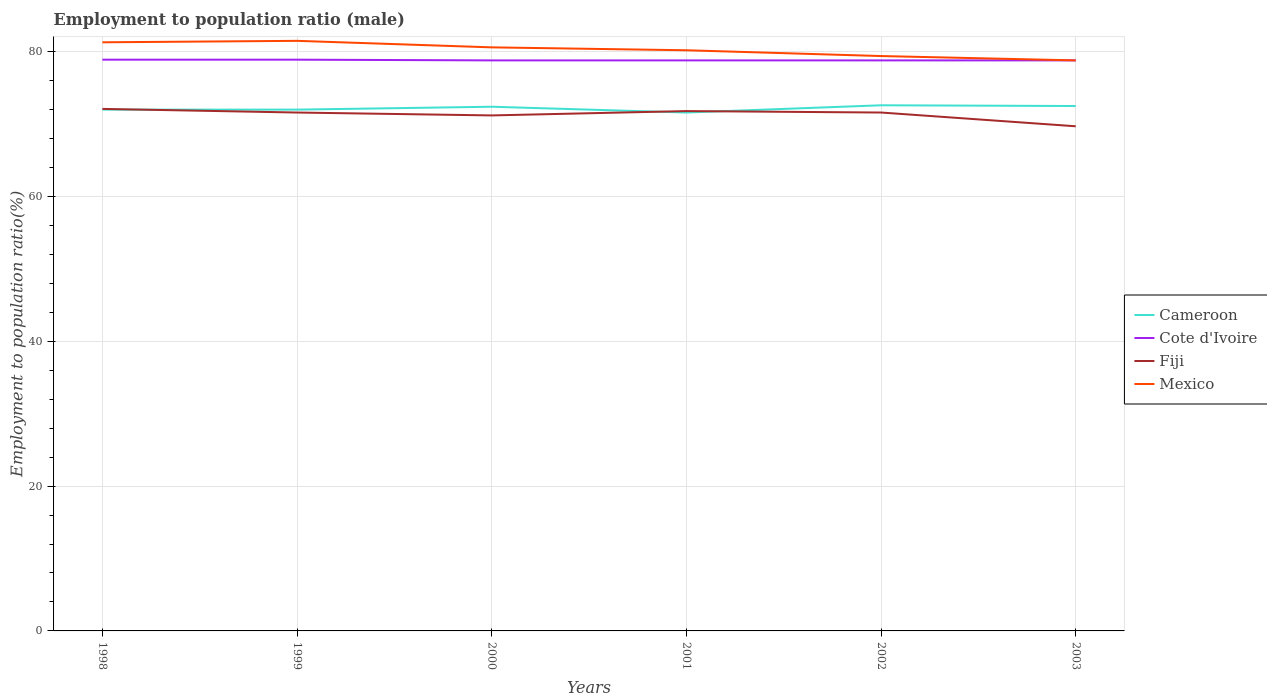Does the line corresponding to Mexico intersect with the line corresponding to Cote d'Ivoire?
Keep it short and to the point. Yes. Across all years, what is the maximum employment to population ratio in Cote d'Ivoire?
Your answer should be very brief. 78.8. What is the total employment to population ratio in Cote d'Ivoire in the graph?
Offer a terse response. 0.1. What is the difference between the highest and the second highest employment to population ratio in Mexico?
Your response must be concise. 2.7. How many lines are there?
Your answer should be very brief. 4. What is the difference between two consecutive major ticks on the Y-axis?
Offer a terse response. 20. Are the values on the major ticks of Y-axis written in scientific E-notation?
Offer a very short reply. No. How many legend labels are there?
Your answer should be compact. 4. How are the legend labels stacked?
Give a very brief answer. Vertical. What is the title of the graph?
Give a very brief answer. Employment to population ratio (male). Does "East Asia (all income levels)" appear as one of the legend labels in the graph?
Make the answer very short. No. What is the Employment to population ratio(%) in Cameroon in 1998?
Offer a terse response. 72. What is the Employment to population ratio(%) in Cote d'Ivoire in 1998?
Your answer should be very brief. 78.9. What is the Employment to population ratio(%) in Fiji in 1998?
Your answer should be compact. 72.1. What is the Employment to population ratio(%) in Mexico in 1998?
Offer a terse response. 81.3. What is the Employment to population ratio(%) in Cote d'Ivoire in 1999?
Offer a very short reply. 78.9. What is the Employment to population ratio(%) of Fiji in 1999?
Give a very brief answer. 71.6. What is the Employment to population ratio(%) in Mexico in 1999?
Offer a terse response. 81.5. What is the Employment to population ratio(%) of Cameroon in 2000?
Provide a succinct answer. 72.4. What is the Employment to population ratio(%) of Cote d'Ivoire in 2000?
Give a very brief answer. 78.8. What is the Employment to population ratio(%) of Fiji in 2000?
Keep it short and to the point. 71.2. What is the Employment to population ratio(%) of Mexico in 2000?
Make the answer very short. 80.6. What is the Employment to population ratio(%) of Cameroon in 2001?
Make the answer very short. 71.6. What is the Employment to population ratio(%) of Cote d'Ivoire in 2001?
Make the answer very short. 78.8. What is the Employment to population ratio(%) in Fiji in 2001?
Give a very brief answer. 71.8. What is the Employment to population ratio(%) of Mexico in 2001?
Offer a terse response. 80.2. What is the Employment to population ratio(%) of Cameroon in 2002?
Provide a succinct answer. 72.6. What is the Employment to population ratio(%) of Cote d'Ivoire in 2002?
Make the answer very short. 78.8. What is the Employment to population ratio(%) in Fiji in 2002?
Provide a short and direct response. 71.6. What is the Employment to population ratio(%) in Mexico in 2002?
Your answer should be compact. 79.4. What is the Employment to population ratio(%) in Cameroon in 2003?
Offer a terse response. 72.5. What is the Employment to population ratio(%) of Cote d'Ivoire in 2003?
Keep it short and to the point. 78.8. What is the Employment to population ratio(%) in Fiji in 2003?
Provide a short and direct response. 69.7. What is the Employment to population ratio(%) in Mexico in 2003?
Your answer should be very brief. 78.8. Across all years, what is the maximum Employment to population ratio(%) in Cameroon?
Provide a short and direct response. 72.6. Across all years, what is the maximum Employment to population ratio(%) in Cote d'Ivoire?
Keep it short and to the point. 78.9. Across all years, what is the maximum Employment to population ratio(%) of Fiji?
Ensure brevity in your answer.  72.1. Across all years, what is the maximum Employment to population ratio(%) in Mexico?
Offer a terse response. 81.5. Across all years, what is the minimum Employment to population ratio(%) in Cameroon?
Your response must be concise. 71.6. Across all years, what is the minimum Employment to population ratio(%) of Cote d'Ivoire?
Keep it short and to the point. 78.8. Across all years, what is the minimum Employment to population ratio(%) of Fiji?
Provide a succinct answer. 69.7. Across all years, what is the minimum Employment to population ratio(%) of Mexico?
Your response must be concise. 78.8. What is the total Employment to population ratio(%) of Cameroon in the graph?
Give a very brief answer. 433.1. What is the total Employment to population ratio(%) in Cote d'Ivoire in the graph?
Ensure brevity in your answer.  473. What is the total Employment to population ratio(%) in Fiji in the graph?
Provide a succinct answer. 428. What is the total Employment to population ratio(%) in Mexico in the graph?
Ensure brevity in your answer.  481.8. What is the difference between the Employment to population ratio(%) in Cote d'Ivoire in 1998 and that in 1999?
Ensure brevity in your answer.  0. What is the difference between the Employment to population ratio(%) of Fiji in 1998 and that in 1999?
Your answer should be very brief. 0.5. What is the difference between the Employment to population ratio(%) in Fiji in 1998 and that in 2000?
Provide a short and direct response. 0.9. What is the difference between the Employment to population ratio(%) of Cameroon in 1998 and that in 2001?
Make the answer very short. 0.4. What is the difference between the Employment to population ratio(%) in Fiji in 1998 and that in 2001?
Offer a very short reply. 0.3. What is the difference between the Employment to population ratio(%) of Mexico in 1998 and that in 2001?
Provide a succinct answer. 1.1. What is the difference between the Employment to population ratio(%) of Cameroon in 1998 and that in 2002?
Offer a terse response. -0.6. What is the difference between the Employment to population ratio(%) of Cote d'Ivoire in 1998 and that in 2002?
Provide a succinct answer. 0.1. What is the difference between the Employment to population ratio(%) in Mexico in 1998 and that in 2002?
Your answer should be compact. 1.9. What is the difference between the Employment to population ratio(%) of Fiji in 1998 and that in 2003?
Ensure brevity in your answer.  2.4. What is the difference between the Employment to population ratio(%) of Cameroon in 1999 and that in 2000?
Your answer should be compact. -0.4. What is the difference between the Employment to population ratio(%) in Cote d'Ivoire in 1999 and that in 2000?
Make the answer very short. 0.1. What is the difference between the Employment to population ratio(%) of Fiji in 1999 and that in 2000?
Make the answer very short. 0.4. What is the difference between the Employment to population ratio(%) in Mexico in 1999 and that in 2000?
Your answer should be very brief. 0.9. What is the difference between the Employment to population ratio(%) of Cameroon in 1999 and that in 2001?
Ensure brevity in your answer.  0.4. What is the difference between the Employment to population ratio(%) of Cote d'Ivoire in 1999 and that in 2001?
Make the answer very short. 0.1. What is the difference between the Employment to population ratio(%) in Mexico in 1999 and that in 2001?
Ensure brevity in your answer.  1.3. What is the difference between the Employment to population ratio(%) of Cameroon in 1999 and that in 2002?
Keep it short and to the point. -0.6. What is the difference between the Employment to population ratio(%) in Cote d'Ivoire in 1999 and that in 2003?
Provide a short and direct response. 0.1. What is the difference between the Employment to population ratio(%) in Mexico in 1999 and that in 2003?
Your answer should be very brief. 2.7. What is the difference between the Employment to population ratio(%) in Cameroon in 2000 and that in 2001?
Provide a succinct answer. 0.8. What is the difference between the Employment to population ratio(%) of Fiji in 2000 and that in 2001?
Your answer should be very brief. -0.6. What is the difference between the Employment to population ratio(%) of Cameroon in 2000 and that in 2002?
Give a very brief answer. -0.2. What is the difference between the Employment to population ratio(%) in Fiji in 2000 and that in 2002?
Give a very brief answer. -0.4. What is the difference between the Employment to population ratio(%) in Cameroon in 2000 and that in 2003?
Offer a terse response. -0.1. What is the difference between the Employment to population ratio(%) of Cote d'Ivoire in 2000 and that in 2003?
Provide a succinct answer. 0. What is the difference between the Employment to population ratio(%) of Mexico in 2000 and that in 2003?
Keep it short and to the point. 1.8. What is the difference between the Employment to population ratio(%) of Fiji in 2001 and that in 2002?
Your response must be concise. 0.2. What is the difference between the Employment to population ratio(%) of Cameroon in 2001 and that in 2003?
Give a very brief answer. -0.9. What is the difference between the Employment to population ratio(%) of Cote d'Ivoire in 2001 and that in 2003?
Keep it short and to the point. 0. What is the difference between the Employment to population ratio(%) in Mexico in 2001 and that in 2003?
Your answer should be very brief. 1.4. What is the difference between the Employment to population ratio(%) of Fiji in 2002 and that in 2003?
Provide a short and direct response. 1.9. What is the difference between the Employment to population ratio(%) in Mexico in 2002 and that in 2003?
Your response must be concise. 0.6. What is the difference between the Employment to population ratio(%) in Cameroon in 1998 and the Employment to population ratio(%) in Cote d'Ivoire in 1999?
Your answer should be very brief. -6.9. What is the difference between the Employment to population ratio(%) in Cameroon in 1998 and the Employment to population ratio(%) in Mexico in 1999?
Your answer should be very brief. -9.5. What is the difference between the Employment to population ratio(%) of Cote d'Ivoire in 1998 and the Employment to population ratio(%) of Fiji in 1999?
Your response must be concise. 7.3. What is the difference between the Employment to population ratio(%) of Fiji in 1998 and the Employment to population ratio(%) of Mexico in 1999?
Provide a succinct answer. -9.4. What is the difference between the Employment to population ratio(%) in Cameroon in 1998 and the Employment to population ratio(%) in Mexico in 2000?
Your answer should be very brief. -8.6. What is the difference between the Employment to population ratio(%) of Fiji in 1998 and the Employment to population ratio(%) of Mexico in 2000?
Keep it short and to the point. -8.5. What is the difference between the Employment to population ratio(%) of Cameroon in 1998 and the Employment to population ratio(%) of Cote d'Ivoire in 2001?
Your answer should be compact. -6.8. What is the difference between the Employment to population ratio(%) of Cameroon in 1998 and the Employment to population ratio(%) of Fiji in 2001?
Your answer should be very brief. 0.2. What is the difference between the Employment to population ratio(%) in Cote d'Ivoire in 1998 and the Employment to population ratio(%) in Fiji in 2001?
Make the answer very short. 7.1. What is the difference between the Employment to population ratio(%) in Cameroon in 1998 and the Employment to population ratio(%) in Cote d'Ivoire in 2002?
Give a very brief answer. -6.8. What is the difference between the Employment to population ratio(%) in Cameroon in 1998 and the Employment to population ratio(%) in Fiji in 2002?
Give a very brief answer. 0.4. What is the difference between the Employment to population ratio(%) of Cameroon in 1998 and the Employment to population ratio(%) of Mexico in 2002?
Your answer should be compact. -7.4. What is the difference between the Employment to population ratio(%) in Fiji in 1998 and the Employment to population ratio(%) in Mexico in 2002?
Provide a succinct answer. -7.3. What is the difference between the Employment to population ratio(%) in Cameroon in 1998 and the Employment to population ratio(%) in Cote d'Ivoire in 2003?
Offer a terse response. -6.8. What is the difference between the Employment to population ratio(%) of Cameroon in 1998 and the Employment to population ratio(%) of Mexico in 2003?
Provide a short and direct response. -6.8. What is the difference between the Employment to population ratio(%) of Cote d'Ivoire in 1998 and the Employment to population ratio(%) of Fiji in 2003?
Your response must be concise. 9.2. What is the difference between the Employment to population ratio(%) of Cote d'Ivoire in 1998 and the Employment to population ratio(%) of Mexico in 2003?
Provide a succinct answer. 0.1. What is the difference between the Employment to population ratio(%) of Fiji in 1998 and the Employment to population ratio(%) of Mexico in 2003?
Give a very brief answer. -6.7. What is the difference between the Employment to population ratio(%) of Cameroon in 1999 and the Employment to population ratio(%) of Mexico in 2000?
Provide a succinct answer. -8.6. What is the difference between the Employment to population ratio(%) of Cote d'Ivoire in 1999 and the Employment to population ratio(%) of Fiji in 2000?
Make the answer very short. 7.7. What is the difference between the Employment to population ratio(%) of Cameroon in 1999 and the Employment to population ratio(%) of Cote d'Ivoire in 2001?
Make the answer very short. -6.8. What is the difference between the Employment to population ratio(%) of Cote d'Ivoire in 1999 and the Employment to population ratio(%) of Fiji in 2001?
Offer a terse response. 7.1. What is the difference between the Employment to population ratio(%) of Cote d'Ivoire in 1999 and the Employment to population ratio(%) of Mexico in 2001?
Provide a succinct answer. -1.3. What is the difference between the Employment to population ratio(%) in Cameroon in 1999 and the Employment to population ratio(%) in Cote d'Ivoire in 2002?
Offer a terse response. -6.8. What is the difference between the Employment to population ratio(%) in Cote d'Ivoire in 1999 and the Employment to population ratio(%) in Fiji in 2002?
Offer a terse response. 7.3. What is the difference between the Employment to population ratio(%) of Cameroon in 1999 and the Employment to population ratio(%) of Cote d'Ivoire in 2003?
Offer a terse response. -6.8. What is the difference between the Employment to population ratio(%) in Cote d'Ivoire in 1999 and the Employment to population ratio(%) in Mexico in 2003?
Make the answer very short. 0.1. What is the difference between the Employment to population ratio(%) of Cameroon in 2000 and the Employment to population ratio(%) of Mexico in 2001?
Keep it short and to the point. -7.8. What is the difference between the Employment to population ratio(%) of Fiji in 2000 and the Employment to population ratio(%) of Mexico in 2001?
Provide a short and direct response. -9. What is the difference between the Employment to population ratio(%) in Cameroon in 2000 and the Employment to population ratio(%) in Cote d'Ivoire in 2002?
Give a very brief answer. -6.4. What is the difference between the Employment to population ratio(%) of Cameroon in 2000 and the Employment to population ratio(%) of Mexico in 2002?
Ensure brevity in your answer.  -7. What is the difference between the Employment to population ratio(%) in Cote d'Ivoire in 2000 and the Employment to population ratio(%) in Fiji in 2002?
Ensure brevity in your answer.  7.2. What is the difference between the Employment to population ratio(%) of Cote d'Ivoire in 2000 and the Employment to population ratio(%) of Mexico in 2002?
Ensure brevity in your answer.  -0.6. What is the difference between the Employment to population ratio(%) of Fiji in 2000 and the Employment to population ratio(%) of Mexico in 2002?
Offer a very short reply. -8.2. What is the difference between the Employment to population ratio(%) in Cameroon in 2000 and the Employment to population ratio(%) in Cote d'Ivoire in 2003?
Keep it short and to the point. -6.4. What is the difference between the Employment to population ratio(%) of Cameroon in 2000 and the Employment to population ratio(%) of Fiji in 2003?
Your answer should be very brief. 2.7. What is the difference between the Employment to population ratio(%) in Cote d'Ivoire in 2000 and the Employment to population ratio(%) in Fiji in 2003?
Give a very brief answer. 9.1. What is the difference between the Employment to population ratio(%) in Cote d'Ivoire in 2000 and the Employment to population ratio(%) in Mexico in 2003?
Your answer should be very brief. 0. What is the difference between the Employment to population ratio(%) of Fiji in 2000 and the Employment to population ratio(%) of Mexico in 2003?
Offer a terse response. -7.6. What is the difference between the Employment to population ratio(%) of Cameroon in 2001 and the Employment to population ratio(%) of Mexico in 2002?
Provide a succinct answer. -7.8. What is the difference between the Employment to population ratio(%) of Cameroon in 2001 and the Employment to population ratio(%) of Cote d'Ivoire in 2003?
Provide a succinct answer. -7.2. What is the difference between the Employment to population ratio(%) in Cameroon in 2001 and the Employment to population ratio(%) in Mexico in 2003?
Provide a succinct answer. -7.2. What is the difference between the Employment to population ratio(%) in Cote d'Ivoire in 2001 and the Employment to population ratio(%) in Fiji in 2003?
Your answer should be compact. 9.1. What is the difference between the Employment to population ratio(%) in Cote d'Ivoire in 2001 and the Employment to population ratio(%) in Mexico in 2003?
Give a very brief answer. 0. What is the difference between the Employment to population ratio(%) in Cameroon in 2002 and the Employment to population ratio(%) in Cote d'Ivoire in 2003?
Give a very brief answer. -6.2. What is the difference between the Employment to population ratio(%) of Cameroon in 2002 and the Employment to population ratio(%) of Fiji in 2003?
Offer a very short reply. 2.9. What is the difference between the Employment to population ratio(%) of Fiji in 2002 and the Employment to population ratio(%) of Mexico in 2003?
Offer a terse response. -7.2. What is the average Employment to population ratio(%) of Cameroon per year?
Your answer should be compact. 72.18. What is the average Employment to population ratio(%) in Cote d'Ivoire per year?
Ensure brevity in your answer.  78.83. What is the average Employment to population ratio(%) of Fiji per year?
Your answer should be compact. 71.33. What is the average Employment to population ratio(%) of Mexico per year?
Offer a terse response. 80.3. In the year 1998, what is the difference between the Employment to population ratio(%) in Cameroon and Employment to population ratio(%) in Cote d'Ivoire?
Give a very brief answer. -6.9. In the year 1998, what is the difference between the Employment to population ratio(%) in Cameroon and Employment to population ratio(%) in Mexico?
Offer a terse response. -9.3. In the year 1998, what is the difference between the Employment to population ratio(%) of Cote d'Ivoire and Employment to population ratio(%) of Fiji?
Offer a terse response. 6.8. In the year 1998, what is the difference between the Employment to population ratio(%) in Fiji and Employment to population ratio(%) in Mexico?
Your answer should be very brief. -9.2. In the year 1999, what is the difference between the Employment to population ratio(%) of Cameroon and Employment to population ratio(%) of Fiji?
Make the answer very short. 0.4. In the year 1999, what is the difference between the Employment to population ratio(%) in Cameroon and Employment to population ratio(%) in Mexico?
Provide a succinct answer. -9.5. In the year 1999, what is the difference between the Employment to population ratio(%) in Cote d'Ivoire and Employment to population ratio(%) in Fiji?
Ensure brevity in your answer.  7.3. In the year 2000, what is the difference between the Employment to population ratio(%) of Cote d'Ivoire and Employment to population ratio(%) of Mexico?
Your response must be concise. -1.8. In the year 2000, what is the difference between the Employment to population ratio(%) in Fiji and Employment to population ratio(%) in Mexico?
Your answer should be compact. -9.4. In the year 2001, what is the difference between the Employment to population ratio(%) in Cameroon and Employment to population ratio(%) in Cote d'Ivoire?
Provide a succinct answer. -7.2. In the year 2002, what is the difference between the Employment to population ratio(%) in Cameroon and Employment to population ratio(%) in Cote d'Ivoire?
Offer a terse response. -6.2. In the year 2002, what is the difference between the Employment to population ratio(%) of Cameroon and Employment to population ratio(%) of Fiji?
Offer a very short reply. 1. In the year 2002, what is the difference between the Employment to population ratio(%) in Cameroon and Employment to population ratio(%) in Mexico?
Ensure brevity in your answer.  -6.8. In the year 2002, what is the difference between the Employment to population ratio(%) in Cote d'Ivoire and Employment to population ratio(%) in Fiji?
Offer a very short reply. 7.2. In the year 2003, what is the difference between the Employment to population ratio(%) in Cameroon and Employment to population ratio(%) in Cote d'Ivoire?
Offer a very short reply. -6.3. What is the ratio of the Employment to population ratio(%) of Mexico in 1998 to that in 1999?
Provide a succinct answer. 1. What is the ratio of the Employment to population ratio(%) of Fiji in 1998 to that in 2000?
Offer a very short reply. 1.01. What is the ratio of the Employment to population ratio(%) in Mexico in 1998 to that in 2000?
Ensure brevity in your answer.  1.01. What is the ratio of the Employment to population ratio(%) of Cameroon in 1998 to that in 2001?
Make the answer very short. 1.01. What is the ratio of the Employment to population ratio(%) in Fiji in 1998 to that in 2001?
Ensure brevity in your answer.  1. What is the ratio of the Employment to population ratio(%) of Mexico in 1998 to that in 2001?
Give a very brief answer. 1.01. What is the ratio of the Employment to population ratio(%) of Cote d'Ivoire in 1998 to that in 2002?
Keep it short and to the point. 1. What is the ratio of the Employment to population ratio(%) in Fiji in 1998 to that in 2002?
Provide a succinct answer. 1.01. What is the ratio of the Employment to population ratio(%) of Mexico in 1998 to that in 2002?
Offer a terse response. 1.02. What is the ratio of the Employment to population ratio(%) of Fiji in 1998 to that in 2003?
Your answer should be compact. 1.03. What is the ratio of the Employment to population ratio(%) in Mexico in 1998 to that in 2003?
Offer a terse response. 1.03. What is the ratio of the Employment to population ratio(%) in Cameroon in 1999 to that in 2000?
Your answer should be very brief. 0.99. What is the ratio of the Employment to population ratio(%) of Cote d'Ivoire in 1999 to that in 2000?
Offer a very short reply. 1. What is the ratio of the Employment to population ratio(%) in Fiji in 1999 to that in 2000?
Provide a succinct answer. 1.01. What is the ratio of the Employment to population ratio(%) in Mexico in 1999 to that in 2000?
Your answer should be compact. 1.01. What is the ratio of the Employment to population ratio(%) in Cameroon in 1999 to that in 2001?
Ensure brevity in your answer.  1.01. What is the ratio of the Employment to population ratio(%) of Cote d'Ivoire in 1999 to that in 2001?
Offer a very short reply. 1. What is the ratio of the Employment to population ratio(%) in Fiji in 1999 to that in 2001?
Your response must be concise. 1. What is the ratio of the Employment to population ratio(%) in Mexico in 1999 to that in 2001?
Offer a terse response. 1.02. What is the ratio of the Employment to population ratio(%) of Cameroon in 1999 to that in 2002?
Provide a short and direct response. 0.99. What is the ratio of the Employment to population ratio(%) in Fiji in 1999 to that in 2002?
Offer a very short reply. 1. What is the ratio of the Employment to population ratio(%) of Mexico in 1999 to that in 2002?
Make the answer very short. 1.03. What is the ratio of the Employment to population ratio(%) in Cameroon in 1999 to that in 2003?
Offer a terse response. 0.99. What is the ratio of the Employment to population ratio(%) in Cote d'Ivoire in 1999 to that in 2003?
Your answer should be compact. 1. What is the ratio of the Employment to population ratio(%) in Fiji in 1999 to that in 2003?
Your response must be concise. 1.03. What is the ratio of the Employment to population ratio(%) of Mexico in 1999 to that in 2003?
Your answer should be compact. 1.03. What is the ratio of the Employment to population ratio(%) in Cameroon in 2000 to that in 2001?
Your answer should be very brief. 1.01. What is the ratio of the Employment to population ratio(%) of Cote d'Ivoire in 2000 to that in 2001?
Your response must be concise. 1. What is the ratio of the Employment to population ratio(%) in Fiji in 2000 to that in 2001?
Make the answer very short. 0.99. What is the ratio of the Employment to population ratio(%) in Mexico in 2000 to that in 2001?
Offer a very short reply. 1. What is the ratio of the Employment to population ratio(%) in Cameroon in 2000 to that in 2002?
Ensure brevity in your answer.  1. What is the ratio of the Employment to population ratio(%) of Cote d'Ivoire in 2000 to that in 2002?
Your response must be concise. 1. What is the ratio of the Employment to population ratio(%) of Fiji in 2000 to that in 2002?
Ensure brevity in your answer.  0.99. What is the ratio of the Employment to population ratio(%) of Mexico in 2000 to that in 2002?
Keep it short and to the point. 1.02. What is the ratio of the Employment to population ratio(%) in Fiji in 2000 to that in 2003?
Give a very brief answer. 1.02. What is the ratio of the Employment to population ratio(%) of Mexico in 2000 to that in 2003?
Your response must be concise. 1.02. What is the ratio of the Employment to population ratio(%) in Cameroon in 2001 to that in 2002?
Your answer should be very brief. 0.99. What is the ratio of the Employment to population ratio(%) in Cameroon in 2001 to that in 2003?
Provide a succinct answer. 0.99. What is the ratio of the Employment to population ratio(%) in Cote d'Ivoire in 2001 to that in 2003?
Offer a terse response. 1. What is the ratio of the Employment to population ratio(%) of Fiji in 2001 to that in 2003?
Keep it short and to the point. 1.03. What is the ratio of the Employment to population ratio(%) in Mexico in 2001 to that in 2003?
Your response must be concise. 1.02. What is the ratio of the Employment to population ratio(%) of Cote d'Ivoire in 2002 to that in 2003?
Provide a short and direct response. 1. What is the ratio of the Employment to population ratio(%) of Fiji in 2002 to that in 2003?
Your answer should be very brief. 1.03. What is the ratio of the Employment to population ratio(%) of Mexico in 2002 to that in 2003?
Ensure brevity in your answer.  1.01. What is the difference between the highest and the second highest Employment to population ratio(%) in Fiji?
Offer a terse response. 0.3. What is the difference between the highest and the lowest Employment to population ratio(%) in Cote d'Ivoire?
Offer a very short reply. 0.1. What is the difference between the highest and the lowest Employment to population ratio(%) in Fiji?
Make the answer very short. 2.4. What is the difference between the highest and the lowest Employment to population ratio(%) of Mexico?
Provide a succinct answer. 2.7. 